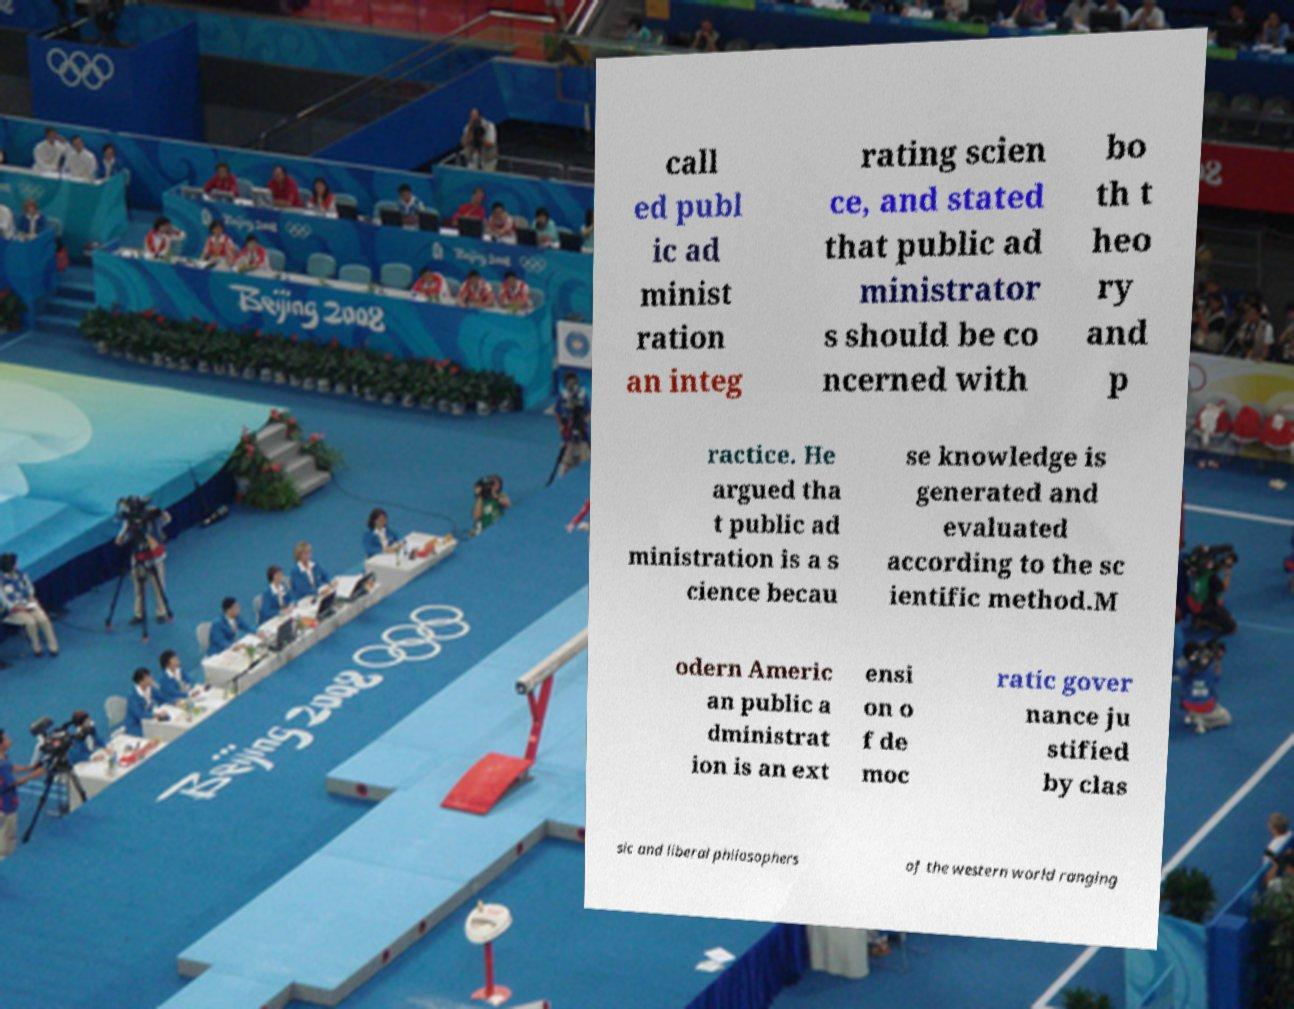I need the written content from this picture converted into text. Can you do that? call ed publ ic ad minist ration an integ rating scien ce, and stated that public ad ministrator s should be co ncerned with bo th t heo ry and p ractice. He argued tha t public ad ministration is a s cience becau se knowledge is generated and evaluated according to the sc ientific method.M odern Americ an public a dministrat ion is an ext ensi on o f de moc ratic gover nance ju stified by clas sic and liberal philosophers of the western world ranging 